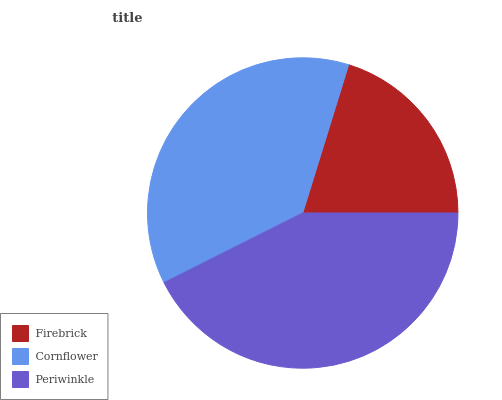Is Firebrick the minimum?
Answer yes or no. Yes. Is Periwinkle the maximum?
Answer yes or no. Yes. Is Cornflower the minimum?
Answer yes or no. No. Is Cornflower the maximum?
Answer yes or no. No. Is Cornflower greater than Firebrick?
Answer yes or no. Yes. Is Firebrick less than Cornflower?
Answer yes or no. Yes. Is Firebrick greater than Cornflower?
Answer yes or no. No. Is Cornflower less than Firebrick?
Answer yes or no. No. Is Cornflower the high median?
Answer yes or no. Yes. Is Cornflower the low median?
Answer yes or no. Yes. Is Periwinkle the high median?
Answer yes or no. No. Is Periwinkle the low median?
Answer yes or no. No. 